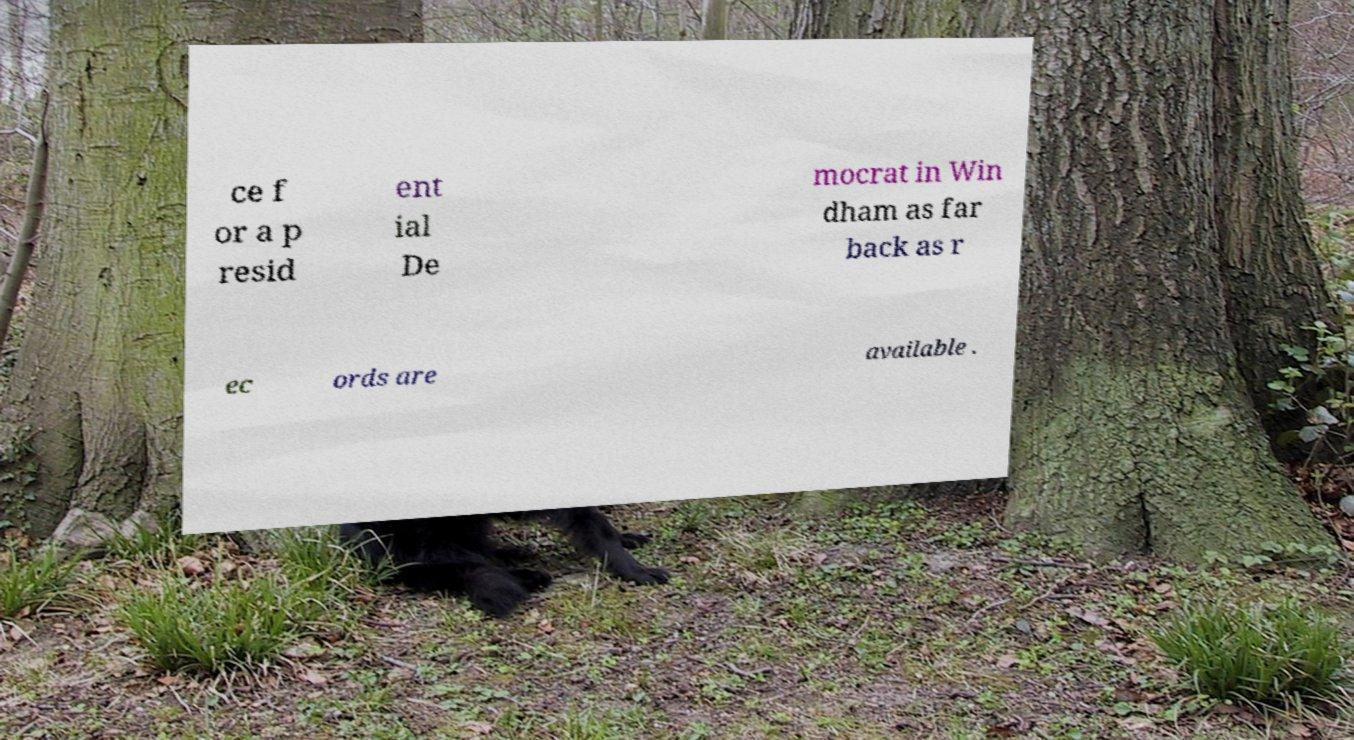For documentation purposes, I need the text within this image transcribed. Could you provide that? ce f or a p resid ent ial De mocrat in Win dham as far back as r ec ords are available . 